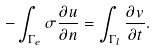Convert formula to latex. <formula><loc_0><loc_0><loc_500><loc_500>- \int _ { \Gamma _ { e } } \sigma \frac { \partial u } { \partial n } = \int _ { \Gamma _ { l } } \frac { \partial v } { \partial t } .</formula> 